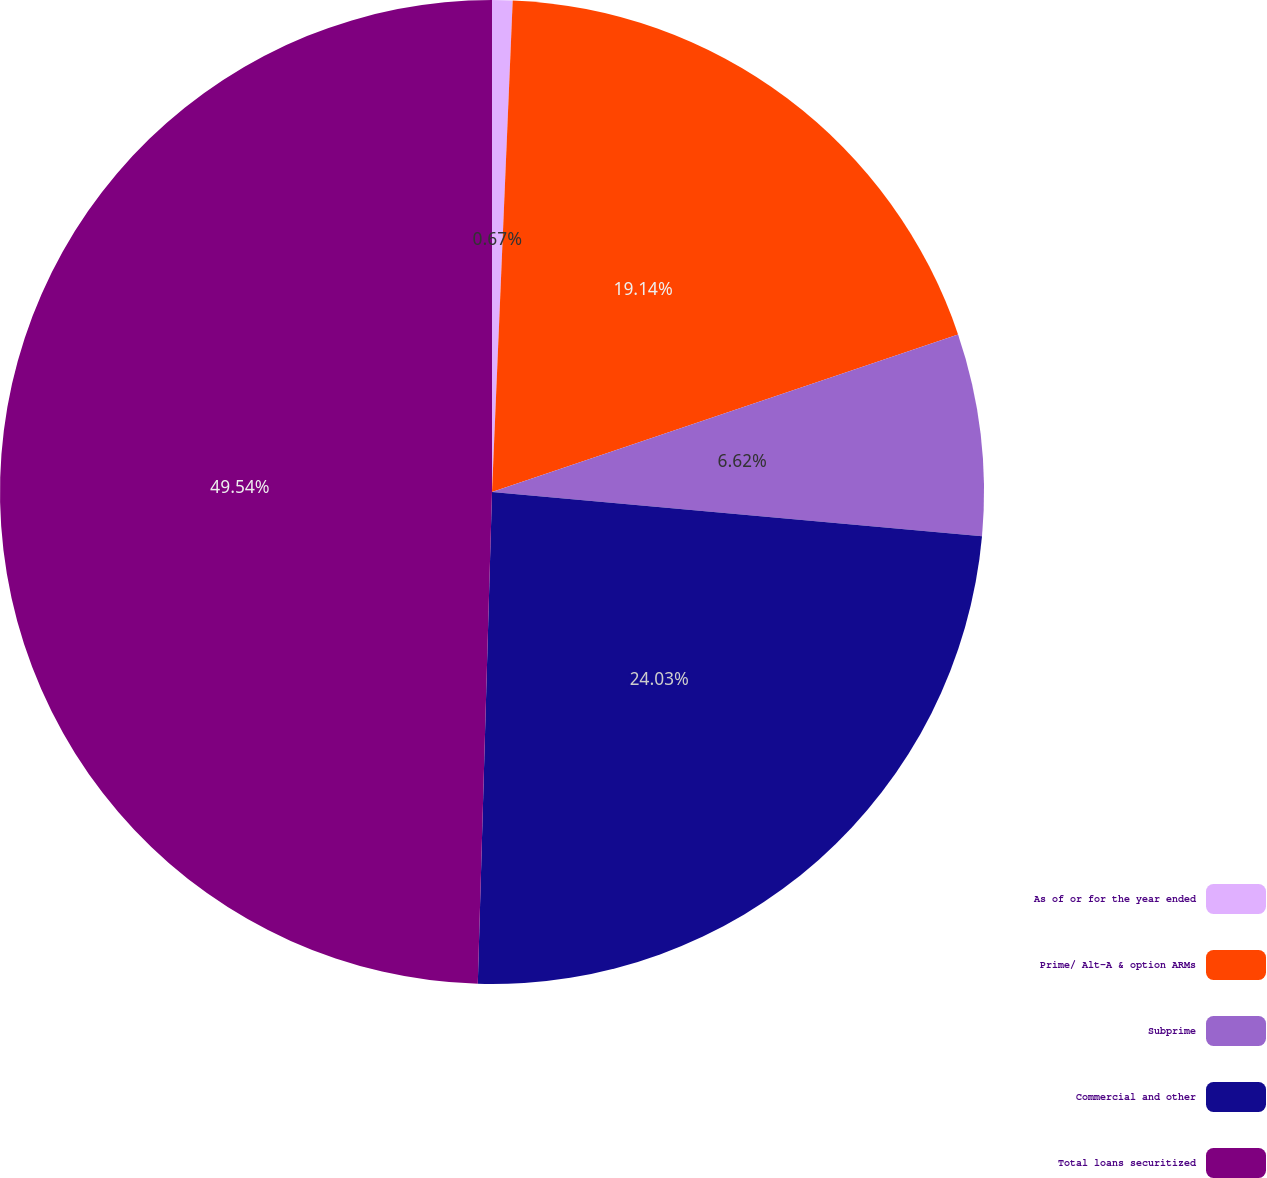Convert chart to OTSL. <chart><loc_0><loc_0><loc_500><loc_500><pie_chart><fcel>As of or for the year ended<fcel>Prime/ Alt-A & option ARMs<fcel>Subprime<fcel>Commercial and other<fcel>Total loans securitized<nl><fcel>0.67%<fcel>19.14%<fcel>6.62%<fcel>24.03%<fcel>49.54%<nl></chart> 